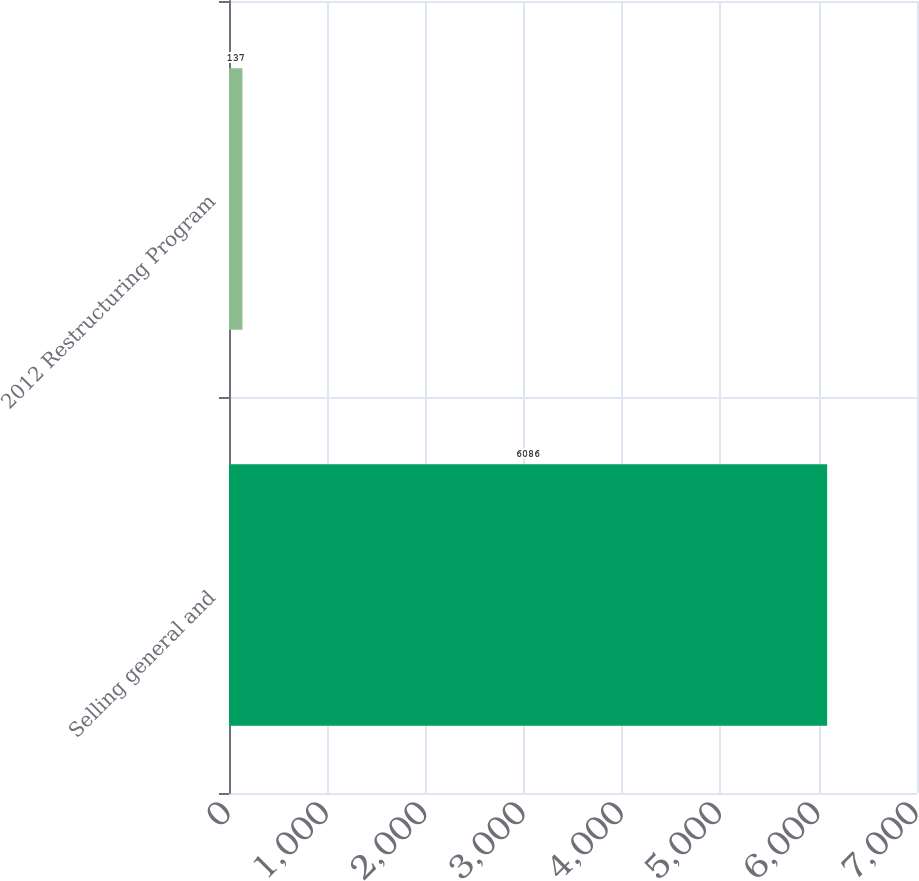<chart> <loc_0><loc_0><loc_500><loc_500><bar_chart><fcel>Selling general and<fcel>2012 Restructuring Program<nl><fcel>6086<fcel>137<nl></chart> 